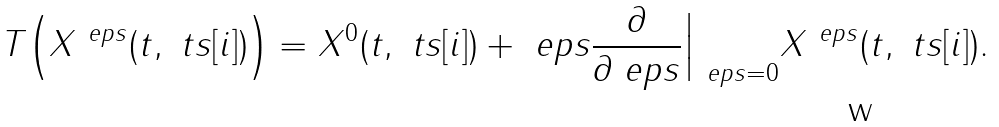<formula> <loc_0><loc_0><loc_500><loc_500>T \Big ( X ^ { \ e p s } ( t , \ t s [ i ] ) \Big ) = X ^ { 0 } ( t , \ t s [ i ] ) + \ e p s \frac { \partial } { \partial \ e p s } \Big | _ { \ e p s = 0 } X ^ { \ e p s } ( t , \ t s [ i ] ) .</formula> 